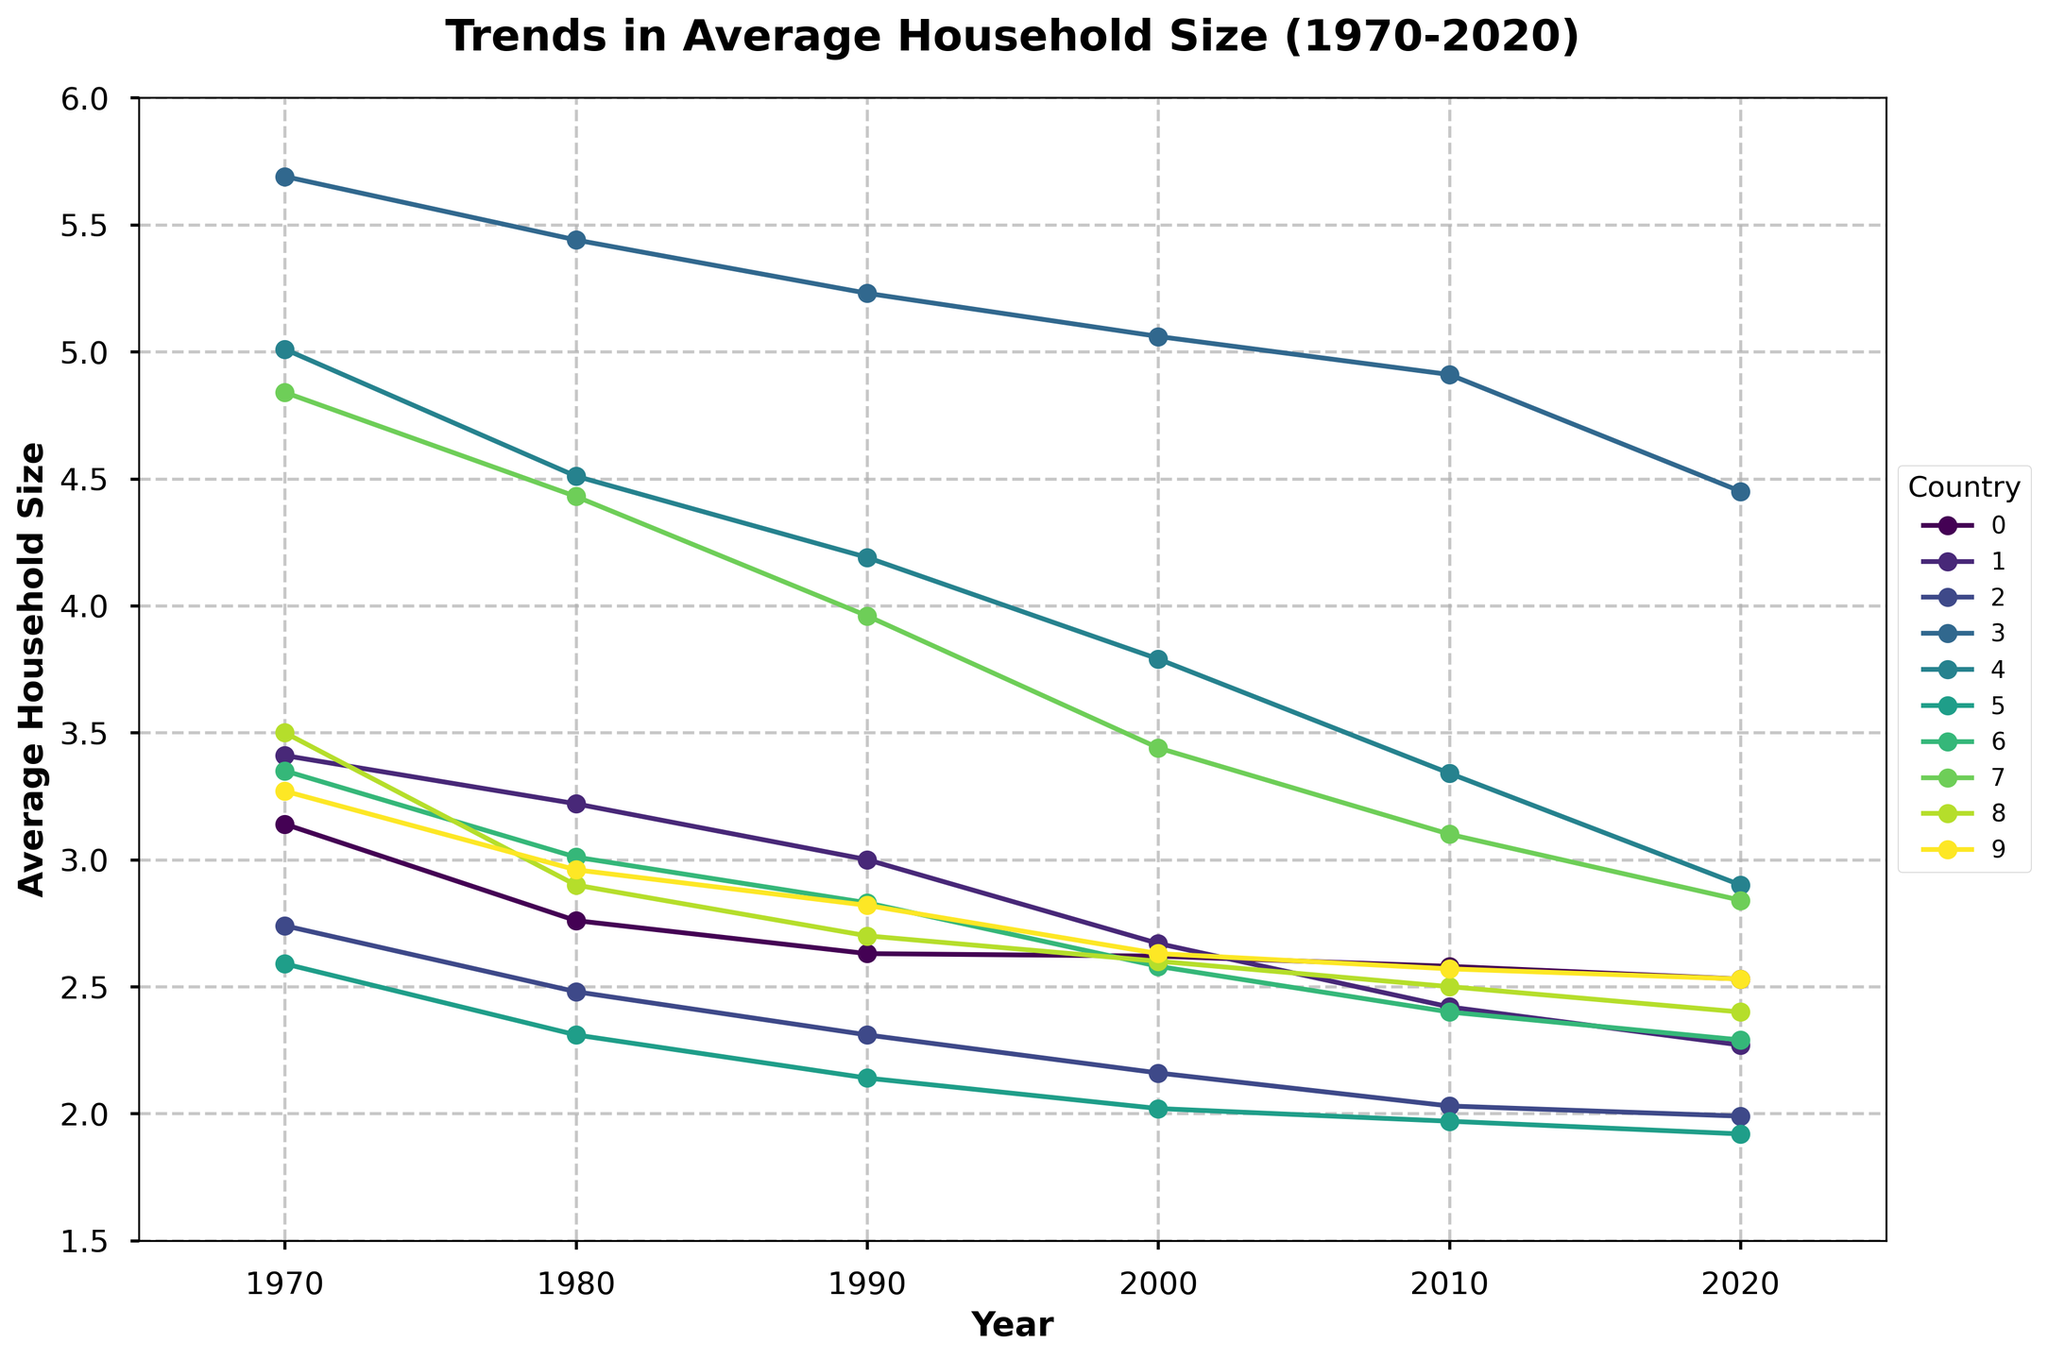What's the trend in the average household size for Japan? The trend in the average household size for Japan shows a consistent decline from 3.41 in 1970 to 2.27 in 2020, indicating that households in Japan are getting smaller over time.
Answer: Decline Which country had the largest decrease in average household size from 1970 to 2020? By calculating the difference between the values for 1970 and 2020 for each country, we see that India had the largest decrease (5.69 - 4.45 = 1.24), followed by Brazil (5.01 - 2.90 = 2.11).
Answer: Brazil In which year did the United States experience the most significant drop in average household size? By examining the values for the United States, we note the changes between consecutive years: 1970 to 1980 (3.14 to 2.76: −0.38), 1980 to 1990 (2.76 to 2.63: −0.13), 1990 to 2000 (2.63 to 2.62: −0.01), 2000 to 2010 (2.62 to 2.58: −0.04), 2010 to 2020 (2.58 to 2.53: −0.05). The most significant drop occurred between 1970 and 1980.
Answer: 1980 Compare the average household size for Canada and Australia in 2020. The average household size for Canada in 2020 is 2.40, and for Australia, it is 2.53. Australia has a slightly larger average household size compared to Canada in 2020.
Answer: Australia Which country maintained the most stable average household size between 1970 and 2020? By examining the changes in household size for each country, Sweden shows the most stability, with values ranging from 2.59 in 1970 to 1.92 in 2020 which amounts to a 0.67 reduction, one of the smallest compared to other countries.
Answer: Sweden What was the overall trend for average household size in developed countries like Germany, Sweden, and Japan? All three developed countries, Germany, Sweden, and Japan, showed a consistent downward trend in average household size from 1970 to 2020.
Answer: Downward trend Which country had the highest average household size in 1990? Reviewing the values for 1990: United States (2.63), Japan (3.00), Germany (2.31), India (5.23), Brazil (4.19), Sweden (2.14), Italy (2.83), China (3.96), Canada (2.70), Australia (2.82). India had the highest average household size at 5.23.
Answer: India What can you infer about the household sizes in Brazil from 2000 to 2020? The data for Brazil shows a steady decline in average household size from 3.79 in 2000 to 2.90 in 2020, suggesting that households in Brazil are consistently getting smaller over this two-decade span.
Answer: Steadily declining How did the household size in China change between 1980 and 2000? The average household size in China decreased from 4.43 in 1980 to 3.44 in 2000, marking a 0.99 decrease over this period. This indicates a significant drop.
Answer: Decreased Which country shows almost the same household size in 2020 and 2010? By comparing the values for 2010 and 2020, the United States has a small change from 2.58 (2010) to 2.53 (2020), showing almost the same household size.
Answer: United States 